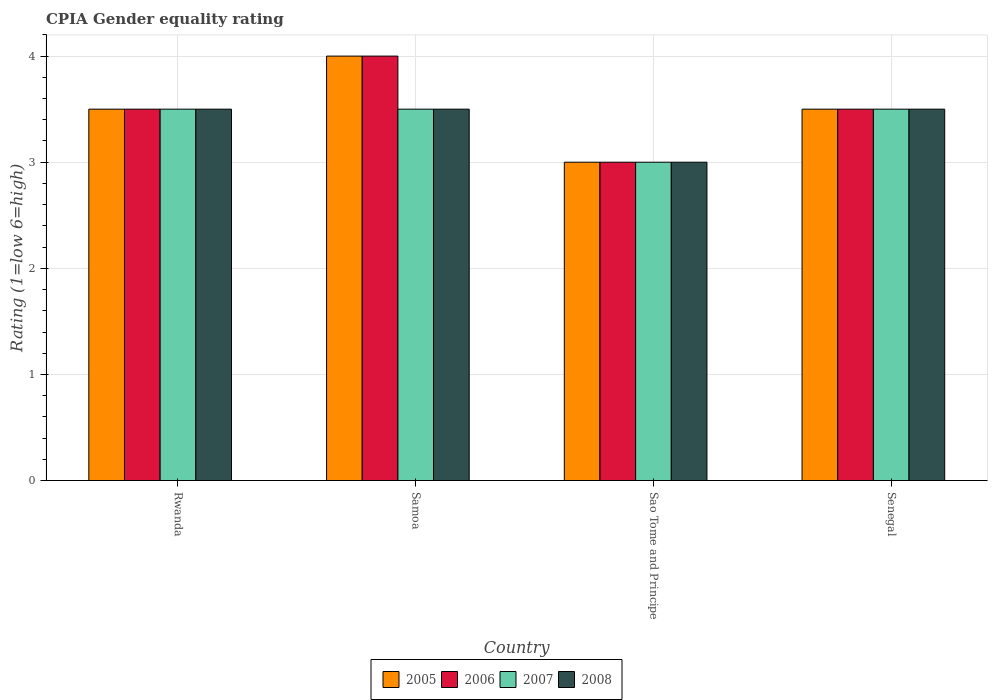How many different coloured bars are there?
Make the answer very short. 4. Are the number of bars per tick equal to the number of legend labels?
Your response must be concise. Yes. Are the number of bars on each tick of the X-axis equal?
Ensure brevity in your answer.  Yes. How many bars are there on the 3rd tick from the left?
Your answer should be very brief. 4. How many bars are there on the 4th tick from the right?
Provide a succinct answer. 4. What is the label of the 4th group of bars from the left?
Provide a succinct answer. Senegal. Across all countries, what is the maximum CPIA rating in 2005?
Your answer should be compact. 4. Across all countries, what is the minimum CPIA rating in 2006?
Give a very brief answer. 3. In which country was the CPIA rating in 2007 maximum?
Offer a very short reply. Rwanda. In which country was the CPIA rating in 2005 minimum?
Keep it short and to the point. Sao Tome and Principe. What is the difference between the CPIA rating in 2005 in Rwanda and that in Samoa?
Give a very brief answer. -0.5. What is the average CPIA rating in 2006 per country?
Give a very brief answer. 3.5. What is the ratio of the CPIA rating in 2008 in Rwanda to that in Senegal?
Your answer should be compact. 1. Is the difference between the CPIA rating in 2006 in Samoa and Sao Tome and Principe greater than the difference between the CPIA rating in 2008 in Samoa and Sao Tome and Principe?
Offer a terse response. Yes. What is the difference between the highest and the second highest CPIA rating in 2006?
Make the answer very short. -0.5. Is it the case that in every country, the sum of the CPIA rating in 2008 and CPIA rating in 2006 is greater than the sum of CPIA rating in 2007 and CPIA rating in 2005?
Your answer should be compact. No. What does the 1st bar from the left in Samoa represents?
Keep it short and to the point. 2005. How many bars are there?
Ensure brevity in your answer.  16. How many countries are there in the graph?
Your answer should be compact. 4. Are the values on the major ticks of Y-axis written in scientific E-notation?
Provide a short and direct response. No. How are the legend labels stacked?
Your answer should be very brief. Horizontal. What is the title of the graph?
Your answer should be very brief. CPIA Gender equality rating. Does "2002" appear as one of the legend labels in the graph?
Provide a short and direct response. No. What is the Rating (1=low 6=high) in 2006 in Rwanda?
Ensure brevity in your answer.  3.5. What is the Rating (1=low 6=high) of 2007 in Rwanda?
Provide a short and direct response. 3.5. What is the Rating (1=low 6=high) in 2008 in Rwanda?
Your response must be concise. 3.5. What is the Rating (1=low 6=high) in 2005 in Samoa?
Provide a short and direct response. 4. What is the Rating (1=low 6=high) of 2007 in Samoa?
Offer a terse response. 3.5. What is the Rating (1=low 6=high) of 2008 in Samoa?
Ensure brevity in your answer.  3.5. What is the Rating (1=low 6=high) of 2005 in Sao Tome and Principe?
Your answer should be very brief. 3. What is the Rating (1=low 6=high) in 2008 in Sao Tome and Principe?
Your answer should be compact. 3. Across all countries, what is the maximum Rating (1=low 6=high) of 2007?
Provide a short and direct response. 3.5. Across all countries, what is the minimum Rating (1=low 6=high) in 2007?
Make the answer very short. 3. What is the total Rating (1=low 6=high) in 2005 in the graph?
Offer a very short reply. 14. What is the total Rating (1=low 6=high) in 2007 in the graph?
Provide a succinct answer. 13.5. What is the difference between the Rating (1=low 6=high) of 2006 in Rwanda and that in Samoa?
Provide a succinct answer. -0.5. What is the difference between the Rating (1=low 6=high) in 2007 in Rwanda and that in Samoa?
Your response must be concise. 0. What is the difference between the Rating (1=low 6=high) in 2005 in Rwanda and that in Sao Tome and Principe?
Keep it short and to the point. 0.5. What is the difference between the Rating (1=low 6=high) of 2006 in Rwanda and that in Sao Tome and Principe?
Offer a terse response. 0.5. What is the difference between the Rating (1=low 6=high) in 2008 in Rwanda and that in Sao Tome and Principe?
Your response must be concise. 0.5. What is the difference between the Rating (1=low 6=high) of 2005 in Rwanda and that in Senegal?
Make the answer very short. 0. What is the difference between the Rating (1=low 6=high) in 2006 in Rwanda and that in Senegal?
Provide a short and direct response. 0. What is the difference between the Rating (1=low 6=high) of 2005 in Samoa and that in Sao Tome and Principe?
Offer a very short reply. 1. What is the difference between the Rating (1=low 6=high) of 2008 in Samoa and that in Sao Tome and Principe?
Your response must be concise. 0.5. What is the difference between the Rating (1=low 6=high) of 2005 in Samoa and that in Senegal?
Your answer should be compact. 0.5. What is the difference between the Rating (1=low 6=high) of 2006 in Samoa and that in Senegal?
Your answer should be compact. 0.5. What is the difference between the Rating (1=low 6=high) of 2006 in Sao Tome and Principe and that in Senegal?
Offer a terse response. -0.5. What is the difference between the Rating (1=low 6=high) of 2008 in Sao Tome and Principe and that in Senegal?
Your answer should be very brief. -0.5. What is the difference between the Rating (1=low 6=high) in 2005 in Rwanda and the Rating (1=low 6=high) in 2006 in Samoa?
Make the answer very short. -0.5. What is the difference between the Rating (1=low 6=high) in 2005 in Rwanda and the Rating (1=low 6=high) in 2007 in Samoa?
Offer a terse response. 0. What is the difference between the Rating (1=low 6=high) of 2005 in Rwanda and the Rating (1=low 6=high) of 2008 in Samoa?
Make the answer very short. 0. What is the difference between the Rating (1=low 6=high) in 2006 in Rwanda and the Rating (1=low 6=high) in 2008 in Samoa?
Provide a succinct answer. 0. What is the difference between the Rating (1=low 6=high) of 2005 in Rwanda and the Rating (1=low 6=high) of 2006 in Sao Tome and Principe?
Your answer should be compact. 0.5. What is the difference between the Rating (1=low 6=high) of 2007 in Rwanda and the Rating (1=low 6=high) of 2008 in Sao Tome and Principe?
Make the answer very short. 0.5. What is the difference between the Rating (1=low 6=high) in 2005 in Rwanda and the Rating (1=low 6=high) in 2007 in Senegal?
Offer a very short reply. 0. What is the difference between the Rating (1=low 6=high) in 2006 in Rwanda and the Rating (1=low 6=high) in 2007 in Senegal?
Provide a short and direct response. 0. What is the difference between the Rating (1=low 6=high) of 2006 in Samoa and the Rating (1=low 6=high) of 2007 in Sao Tome and Principe?
Your response must be concise. 1. What is the difference between the Rating (1=low 6=high) of 2005 in Samoa and the Rating (1=low 6=high) of 2007 in Senegal?
Offer a terse response. 0.5. What is the difference between the Rating (1=low 6=high) of 2006 in Samoa and the Rating (1=low 6=high) of 2007 in Senegal?
Provide a succinct answer. 0.5. What is the difference between the Rating (1=low 6=high) in 2005 in Sao Tome and Principe and the Rating (1=low 6=high) in 2007 in Senegal?
Ensure brevity in your answer.  -0.5. What is the difference between the Rating (1=low 6=high) in 2006 in Sao Tome and Principe and the Rating (1=low 6=high) in 2007 in Senegal?
Offer a terse response. -0.5. What is the average Rating (1=low 6=high) in 2005 per country?
Make the answer very short. 3.5. What is the average Rating (1=low 6=high) of 2007 per country?
Make the answer very short. 3.38. What is the average Rating (1=low 6=high) of 2008 per country?
Your answer should be very brief. 3.38. What is the difference between the Rating (1=low 6=high) of 2005 and Rating (1=low 6=high) of 2006 in Rwanda?
Make the answer very short. 0. What is the difference between the Rating (1=low 6=high) in 2005 and Rating (1=low 6=high) in 2007 in Rwanda?
Keep it short and to the point. 0. What is the difference between the Rating (1=low 6=high) of 2005 and Rating (1=low 6=high) of 2008 in Rwanda?
Your response must be concise. 0. What is the difference between the Rating (1=low 6=high) of 2006 and Rating (1=low 6=high) of 2007 in Rwanda?
Keep it short and to the point. 0. What is the difference between the Rating (1=low 6=high) of 2006 and Rating (1=low 6=high) of 2008 in Samoa?
Give a very brief answer. 0.5. What is the difference between the Rating (1=low 6=high) of 2005 and Rating (1=low 6=high) of 2006 in Sao Tome and Principe?
Give a very brief answer. 0. What is the difference between the Rating (1=low 6=high) of 2005 and Rating (1=low 6=high) of 2007 in Sao Tome and Principe?
Make the answer very short. 0. What is the difference between the Rating (1=low 6=high) of 2005 and Rating (1=low 6=high) of 2008 in Sao Tome and Principe?
Your response must be concise. 0. What is the difference between the Rating (1=low 6=high) in 2006 and Rating (1=low 6=high) in 2008 in Sao Tome and Principe?
Offer a terse response. 0. What is the difference between the Rating (1=low 6=high) of 2007 and Rating (1=low 6=high) of 2008 in Sao Tome and Principe?
Keep it short and to the point. 0. What is the difference between the Rating (1=low 6=high) in 2005 and Rating (1=low 6=high) in 2006 in Senegal?
Ensure brevity in your answer.  0. What is the difference between the Rating (1=low 6=high) of 2005 and Rating (1=low 6=high) of 2008 in Senegal?
Provide a short and direct response. 0. What is the difference between the Rating (1=low 6=high) in 2006 and Rating (1=low 6=high) in 2008 in Senegal?
Your answer should be very brief. 0. What is the ratio of the Rating (1=low 6=high) of 2006 in Rwanda to that in Samoa?
Offer a terse response. 0.88. What is the ratio of the Rating (1=low 6=high) of 2005 in Rwanda to that in Sao Tome and Principe?
Offer a terse response. 1.17. What is the ratio of the Rating (1=low 6=high) of 2006 in Rwanda to that in Sao Tome and Principe?
Offer a terse response. 1.17. What is the ratio of the Rating (1=low 6=high) in 2006 in Rwanda to that in Senegal?
Make the answer very short. 1. What is the ratio of the Rating (1=low 6=high) of 2007 in Rwanda to that in Senegal?
Offer a terse response. 1. What is the ratio of the Rating (1=low 6=high) of 2008 in Rwanda to that in Senegal?
Your answer should be compact. 1. What is the ratio of the Rating (1=low 6=high) in 2005 in Samoa to that in Sao Tome and Principe?
Give a very brief answer. 1.33. What is the ratio of the Rating (1=low 6=high) of 2006 in Samoa to that in Sao Tome and Principe?
Your answer should be very brief. 1.33. What is the ratio of the Rating (1=low 6=high) of 2005 in Samoa to that in Senegal?
Provide a short and direct response. 1.14. What is the ratio of the Rating (1=low 6=high) in 2006 in Samoa to that in Senegal?
Provide a succinct answer. 1.14. What is the ratio of the Rating (1=low 6=high) of 2008 in Samoa to that in Senegal?
Offer a very short reply. 1. What is the ratio of the Rating (1=low 6=high) of 2006 in Sao Tome and Principe to that in Senegal?
Provide a short and direct response. 0.86. What is the ratio of the Rating (1=low 6=high) of 2008 in Sao Tome and Principe to that in Senegal?
Make the answer very short. 0.86. What is the difference between the highest and the second highest Rating (1=low 6=high) of 2006?
Make the answer very short. 0.5. What is the difference between the highest and the second highest Rating (1=low 6=high) of 2007?
Offer a very short reply. 0. What is the difference between the highest and the lowest Rating (1=low 6=high) in 2006?
Your response must be concise. 1. What is the difference between the highest and the lowest Rating (1=low 6=high) of 2007?
Provide a succinct answer. 0.5. What is the difference between the highest and the lowest Rating (1=low 6=high) in 2008?
Offer a terse response. 0.5. 